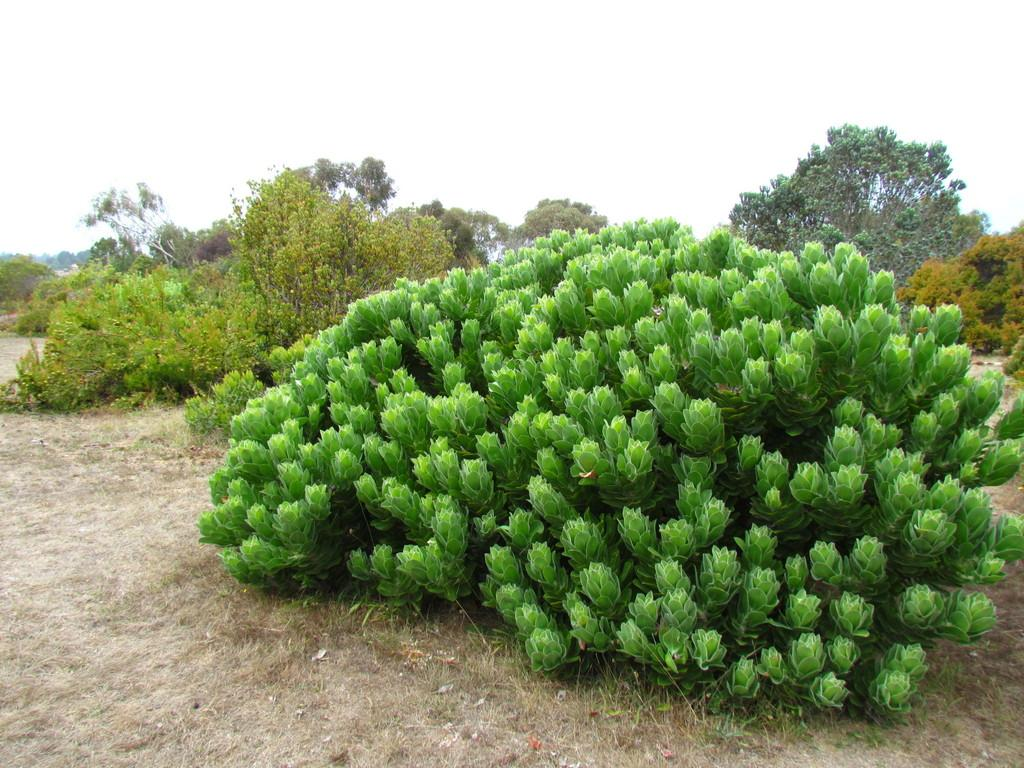What type of ground surface is visible in the image? There is a ground surface with plants in the image. Can you describe the plants in the image? There are plants visible both in the foreground and background of the image. What can be seen in the background of the image besides plants? The sky is visible in the background of the image. How many cakes are wrapped in the parcel in the image? There are no cakes or parcels present in the image; it features a ground surface with plants and a visible sky in the background. 